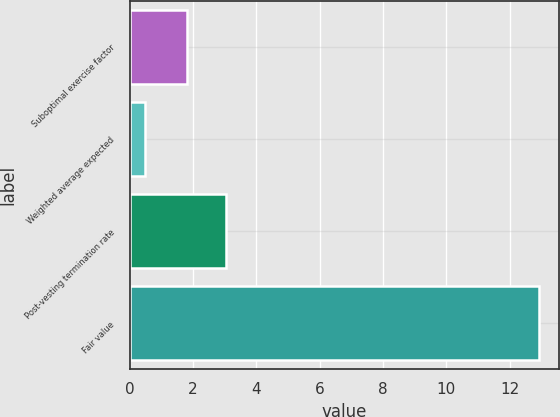<chart> <loc_0><loc_0><loc_500><loc_500><bar_chart><fcel>Suboptimal exercise factor<fcel>Weighted average expected<fcel>Post-vesting termination rate<fcel>Fair value<nl><fcel>1.81<fcel>0.49<fcel>3.05<fcel>12.91<nl></chart> 